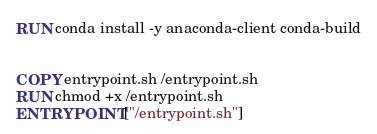<code> <loc_0><loc_0><loc_500><loc_500><_Dockerfile_>
RUN conda install -y anaconda-client conda-build


COPY entrypoint.sh /entrypoint.sh
RUN chmod +x /entrypoint.sh
ENTRYPOINT ["/entrypoint.sh"]
</code> 